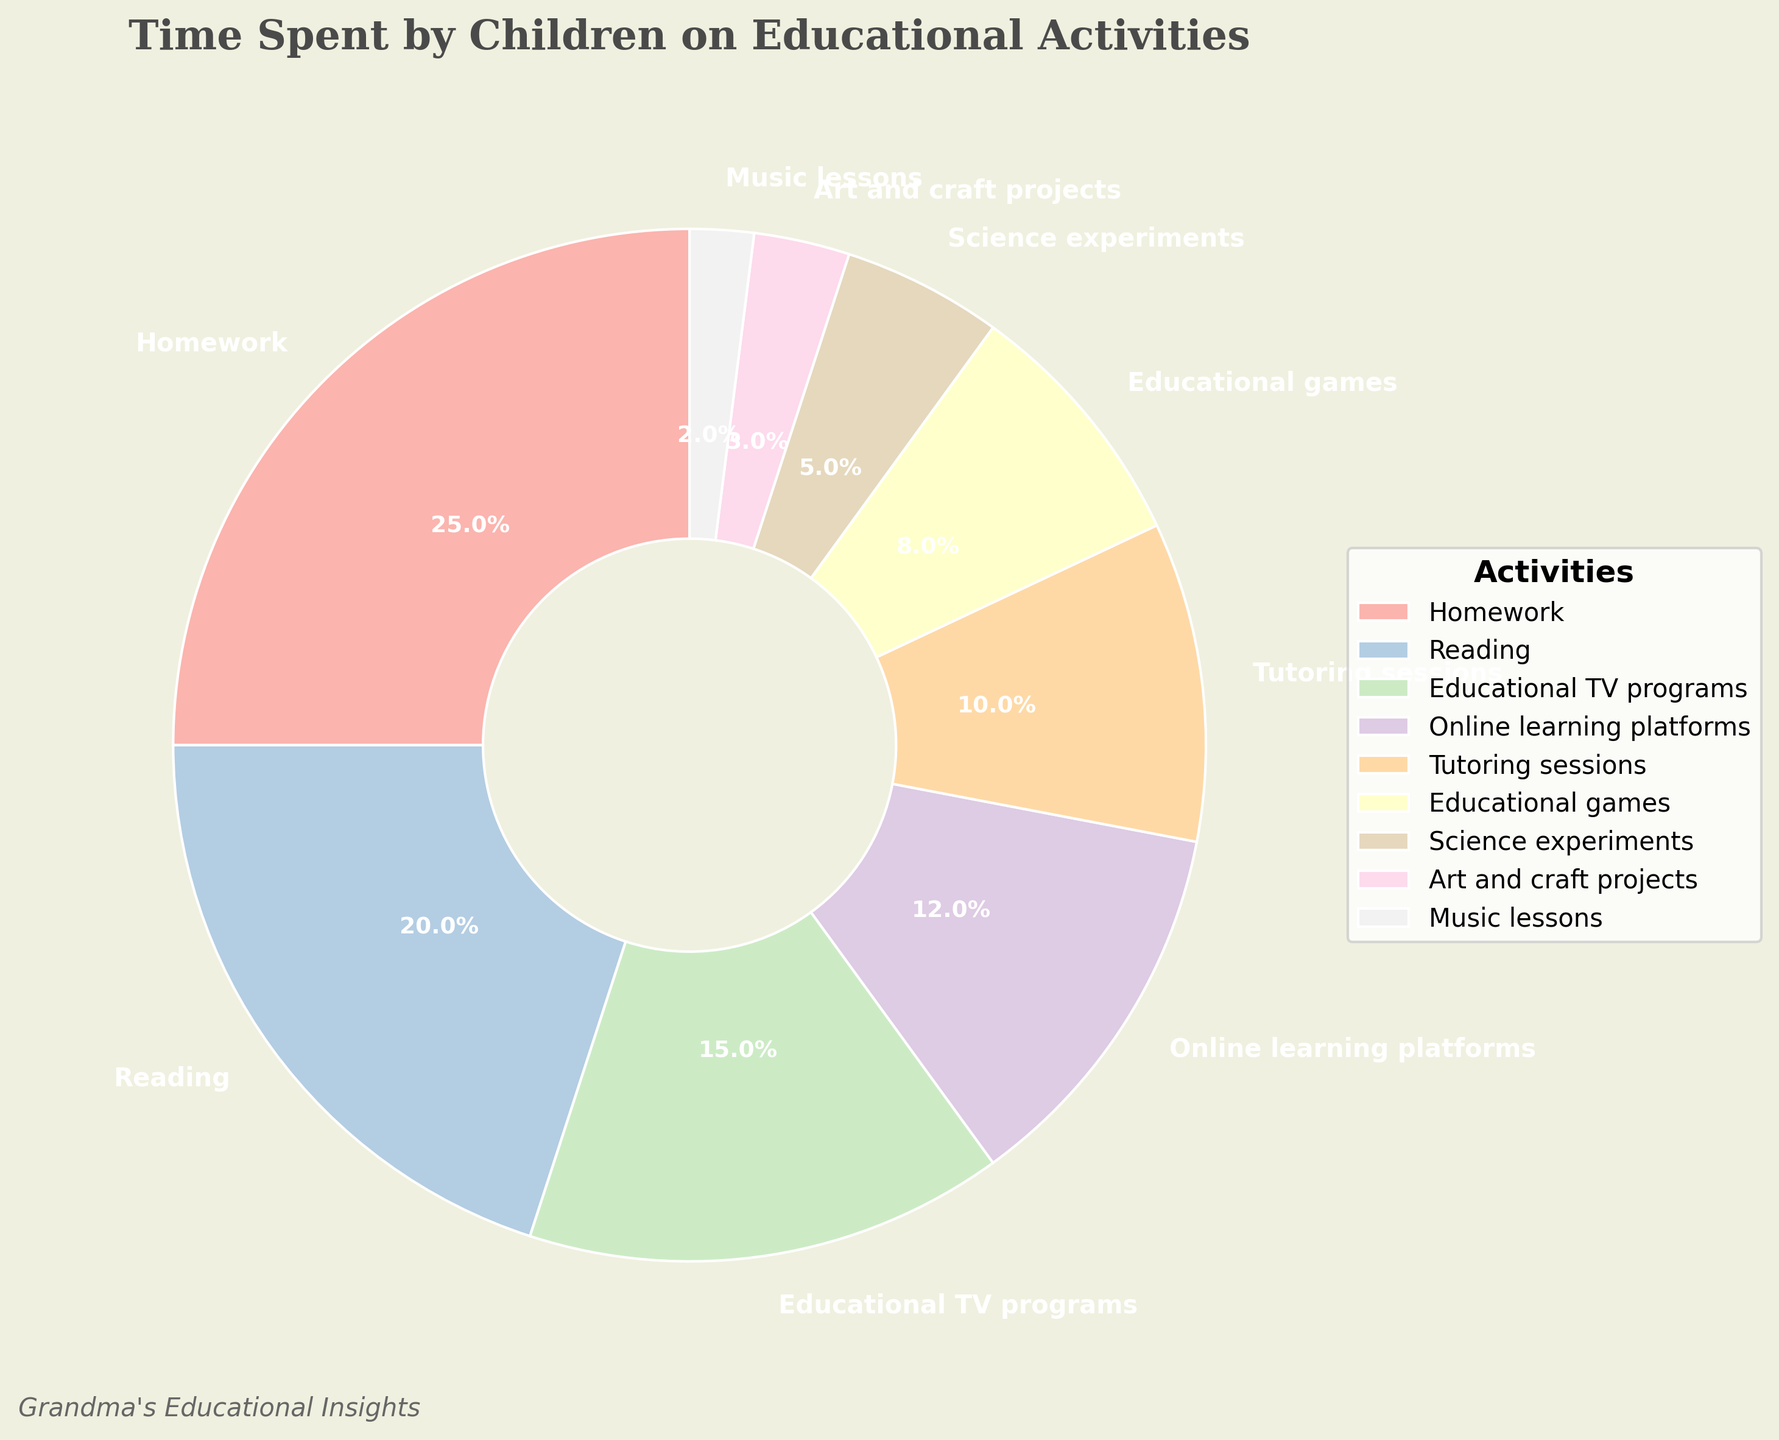Which educational activity takes up the most time? Homework takes up 25% of the time, which is the highest percentage among all the activities listed.
Answer: Homework What's the combined percentage of time spent on Reading and Homework? Reading takes up 20% and Homework takes up 25%. Adding these together gives 20% + 25% = 45%.
Answer: 45% Is the percentage of time spent on Online learning platforms greater or less than Tutoring sessions? Online learning platforms take up 12%, whereas Tutoring sessions take up 10%. 12% is greater than 10%.
Answer: Greater What is the total percentage of time spent on Education TV programs, Science experiments and Art and craft projects? Educational TV programs are 15%, Science experiments are 5%, and Art and craft projects are 3%. Adding these together gives 15% + 5% + 3% = 23%.
Answer: 23% Which activity takes up more time: Educational games or Music lessons? Educational Games take up 8% while Music Lessons take up 2%. Comparing 8% and 2%, 8% is greater.
Answer: Educational games What is the difference in percentage points between time spent on Reading and Educational TV programs? Reading takes up 20%, and Educational TV programs take up 15%. The difference is calculated as 20% - 15% = 5%.
Answer: 5% What is the sum of the percentages spent on Tutoring sessions and Educational games? Tutoring sessions take up 10%, and Educational games take up 8%. The sum is 10% + 8% = 18%.
Answer: 18% Which activity has a smaller percentage: Science experiments or Art and craft projects? Science experiments take up 5%, while Art and craft projects take up 3%. Comparing 5% and 3%, 3% is smaller.
Answer: Art and craft projects What's the average percentage of time spent on Music lessons, Art and craft projects, and Science experiments combined? Music lessons are 2%, Art and craft projects are 3%, Science experiments are 5%. Adding these together gives 2% + 3% + 5% = 10%. The average is 10% / 3 = 3.33%.
Answer: 3.33% Based on the chart, if time allocation ordered from highest to lowest, which activity is right in the middle? Ordering the percentages from highest to lowest: Homework (25%), Reading (20%), Educational TV programs (15%), Online learning platforms (12%), Tutoring sessions (10%), Educational games (8%), Science experiments (5%), Art and craft projects (3%), Music lessons (2%). The middle activity in this order is Tutoring sessions.
Answer: Tutoring sessions 